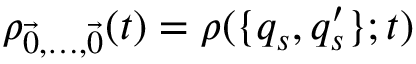<formula> <loc_0><loc_0><loc_500><loc_500>\rho _ { \vec { 0 } , \dots , \vec { 0 } } ( t ) = \rho ( \{ q _ { s } , q _ { s } ^ { \prime } \} ; t )</formula> 